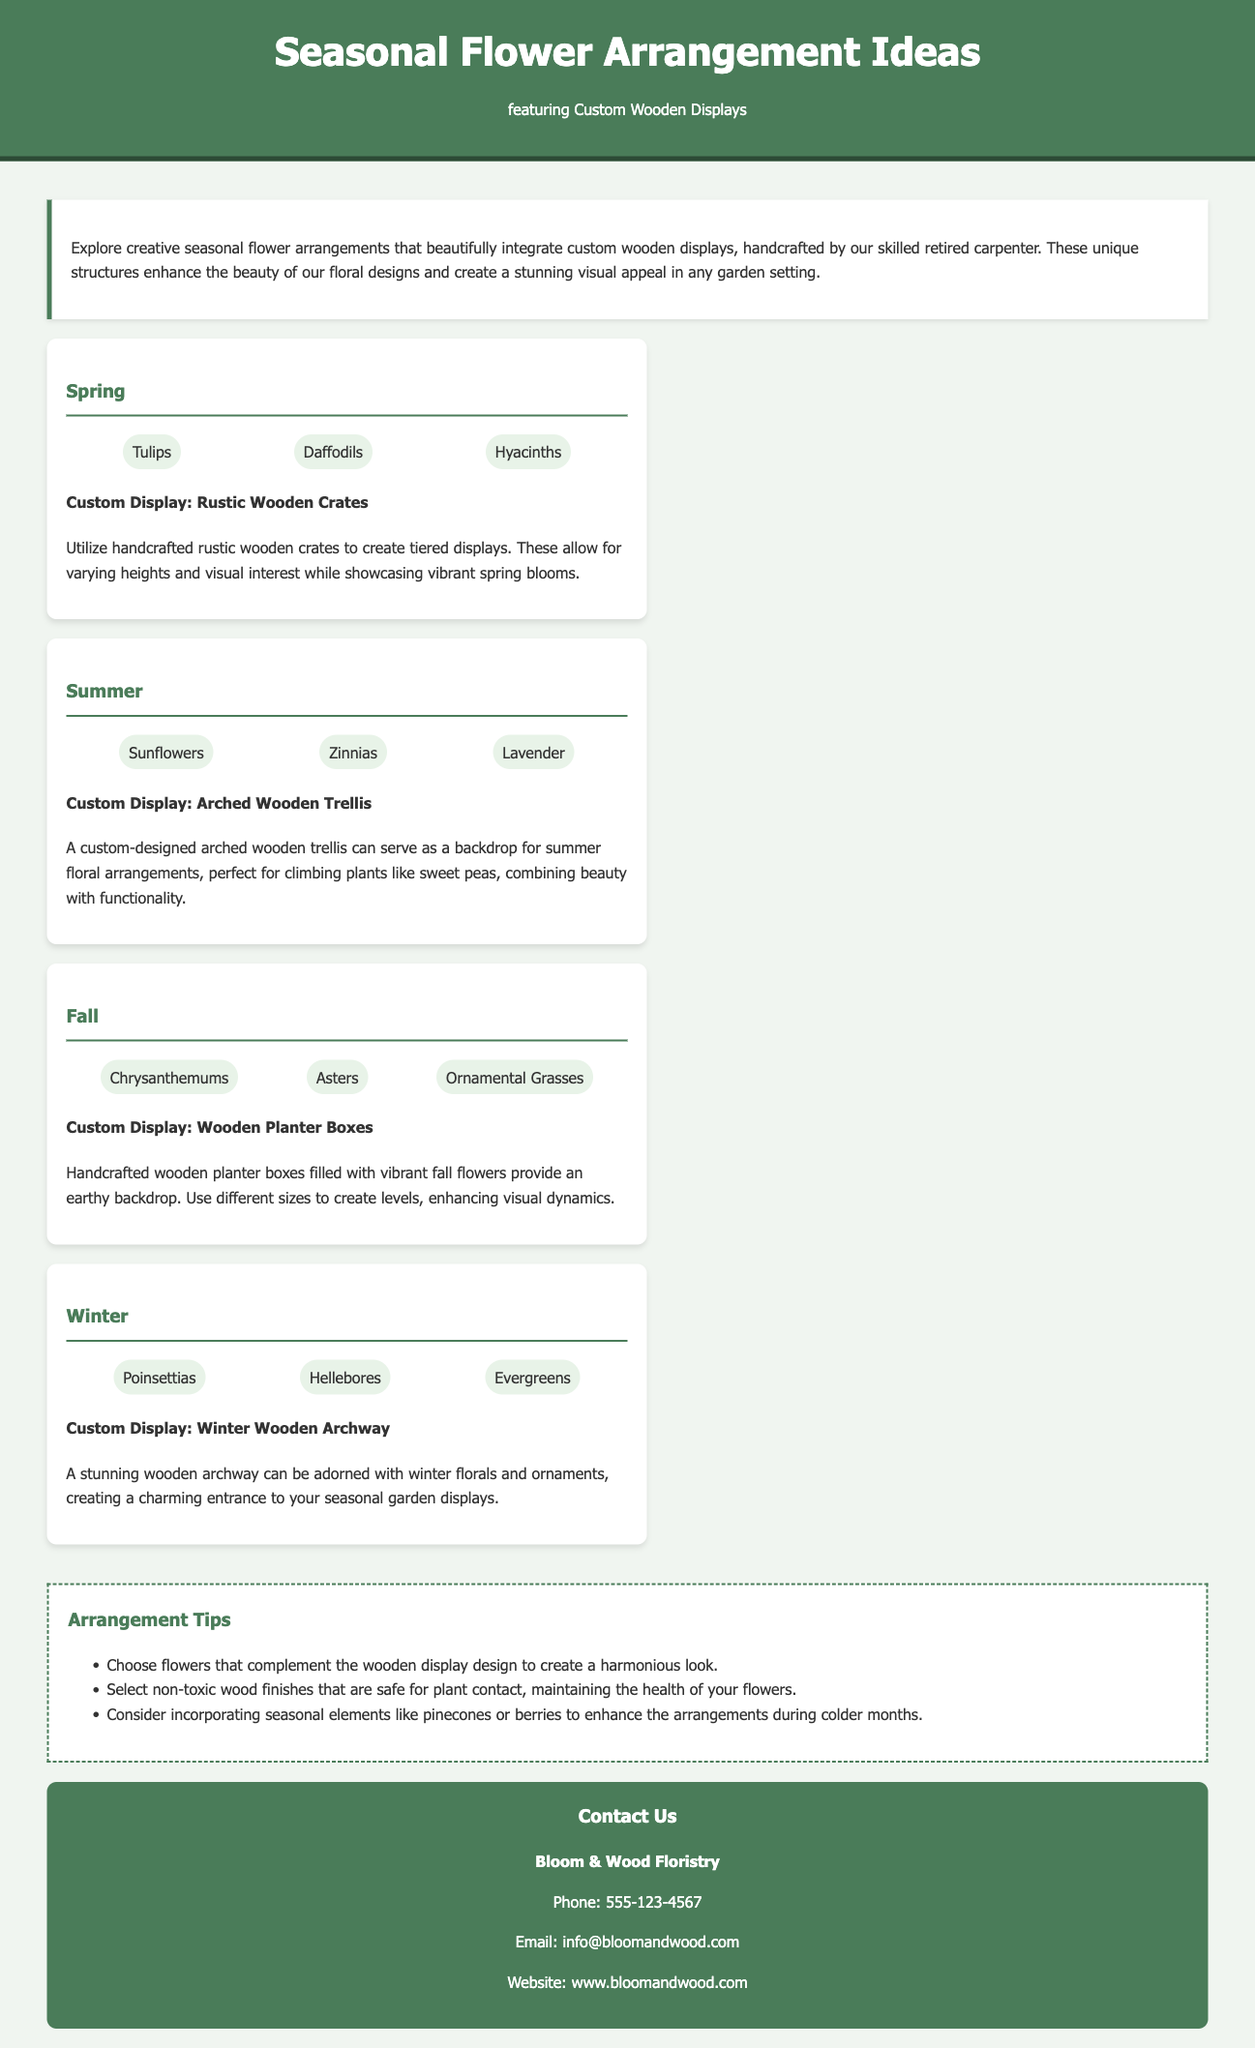What flowers are featured in the Spring section? The Spring section includes specific flowers such as Tulips, Daffodils, and Hyacinths.
Answer: Tulips, Daffodils, Hyacinths What custom display is suggested for Summer arrangements? The Summer arrangements recommend using a custom-designed arched wooden trellis as a display.
Answer: Arched Wooden Trellis How many arrangement tips are provided? The document lists three tips for flower arrangements.
Answer: 3 What type of flowers are suggested for Winter? The Winter section suggests Poinsettias, Hellebores, and Evergreens.
Answer: Poinsettias, Hellebores, Evergreens What is the background color of the contact section? The contact section is designed with a background color of green.
Answer: Green What season features ornamental grasses? The Fall section includes ornamental grasses in its flowers list.
Answer: Fall What are the planter displays used for Fall arrangements? The Fall arrangements incorporate handcrafted wooden planter boxes as the display option.
Answer: Wooden Planter Boxes What is the purpose of the rustic wooden crates in Spring? The rustic wooden crates are used to create tiered displays that enhance the visual interest of spring flowers.
Answer: Tiered displays Which organization is listed in the contact information? The contact information lists "Bloom & Wood Floristry" as the organization.
Answer: Bloom & Wood Floristry 